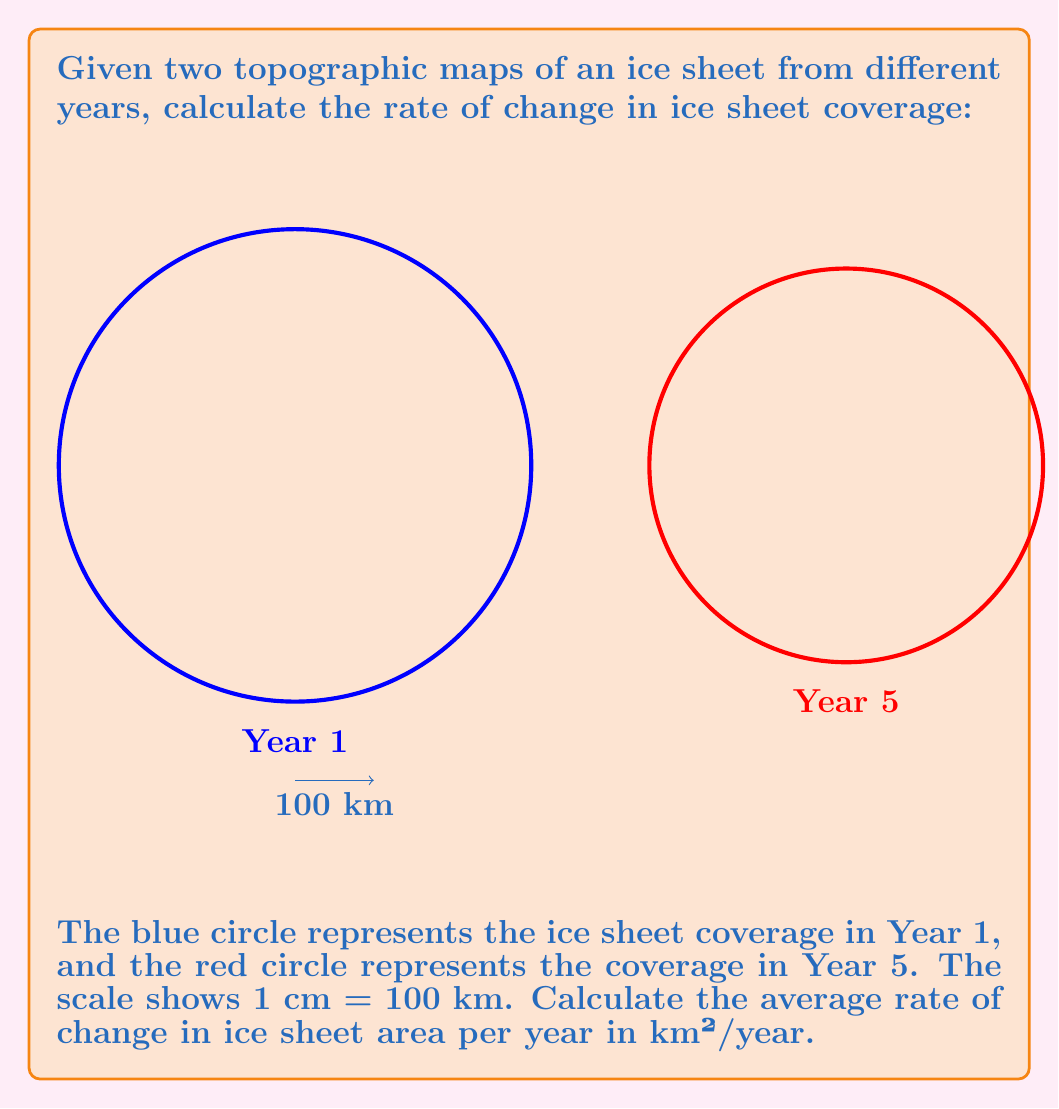Help me with this question. To solve this problem, we need to follow these steps:

1. Calculate the areas of both ice sheets:
   Area = $\pi r^2$, where $r$ is the radius in km.

   For Year 1 (blue): 
   Radius = 3 cm * 100 km/cm = 300 km
   Area_1 = $\pi (300)^2 = 282,743.34$ km²

   For Year 5 (red):
   Radius = 2.5 cm * 100 km/cm = 250 km
   Area_5 = $\pi (250)^2 = 196,349.54$ km²

2. Calculate the total change in area:
   $\Delta$Area = Area_1 - Area_5 = 282,743.34 - 196,349.54 = 86,393.80 km²

3. Calculate the rate of change per year:
   Time span = 5 years - 1 year = 4 years
   Rate of change = $\frac{\Delta\text{Area}}{\Delta\text{Time}} = \frac{86,393.80 \text{ km}^2}{4 \text{ years}} = 21,598.45$ km²/year

Therefore, the average rate of change in ice sheet area is 21,598.45 km²/year.
Answer: 21,598.45 km²/year 